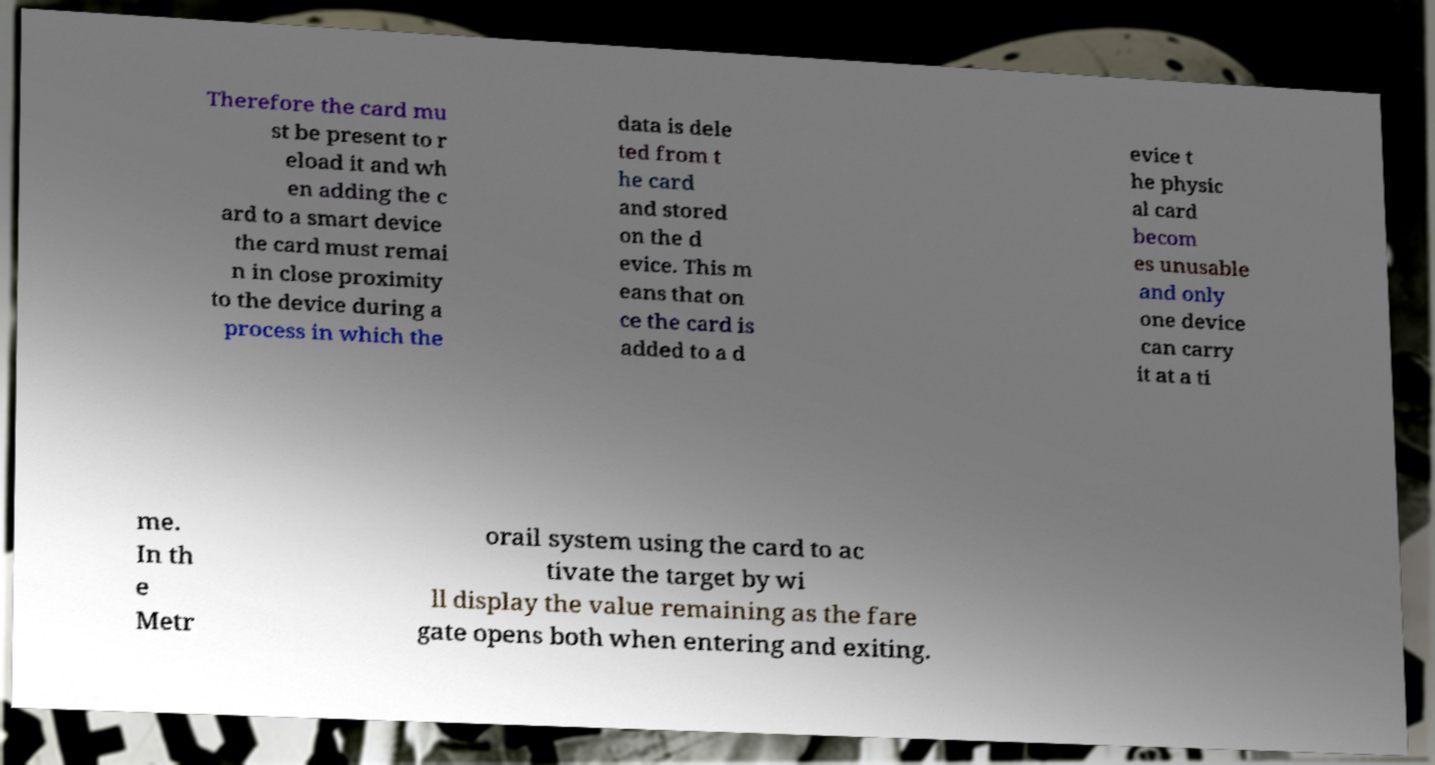Could you extract and type out the text from this image? Therefore the card mu st be present to r eload it and wh en adding the c ard to a smart device the card must remai n in close proximity to the device during a process in which the data is dele ted from t he card and stored on the d evice. This m eans that on ce the card is added to a d evice t he physic al card becom es unusable and only one device can carry it at a ti me. In th e Metr orail system using the card to ac tivate the target by wi ll display the value remaining as the fare gate opens both when entering and exiting. 